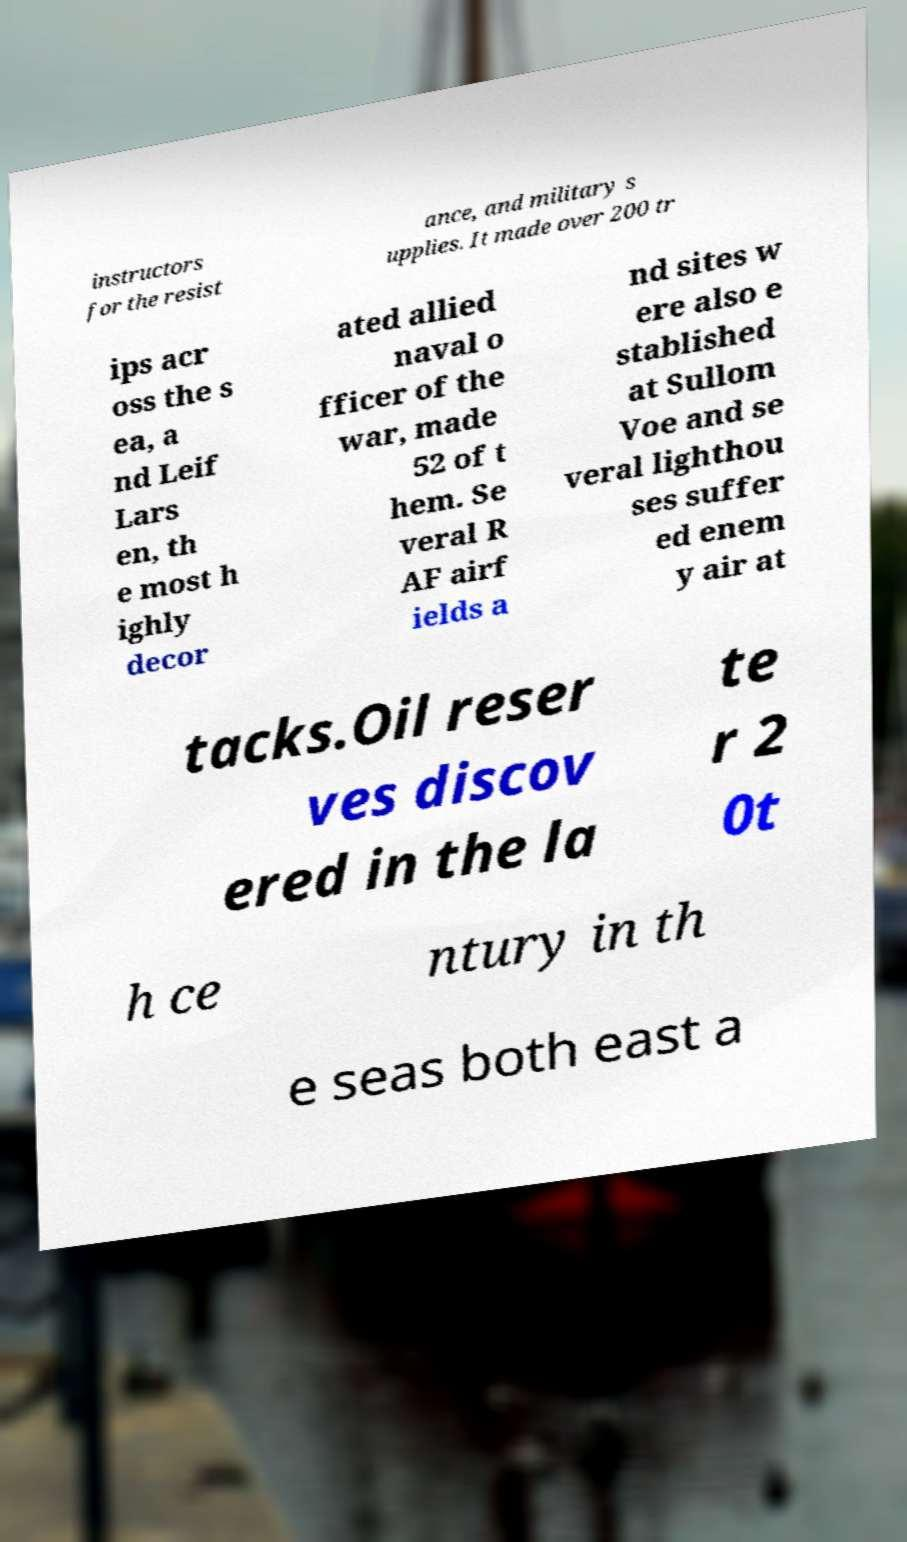Can you read and provide the text displayed in the image?This photo seems to have some interesting text. Can you extract and type it out for me? instructors for the resist ance, and military s upplies. It made over 200 tr ips acr oss the s ea, a nd Leif Lars en, th e most h ighly decor ated allied naval o fficer of the war, made 52 of t hem. Se veral R AF airf ields a nd sites w ere also e stablished at Sullom Voe and se veral lighthou ses suffer ed enem y air at tacks.Oil reser ves discov ered in the la te r 2 0t h ce ntury in th e seas both east a 